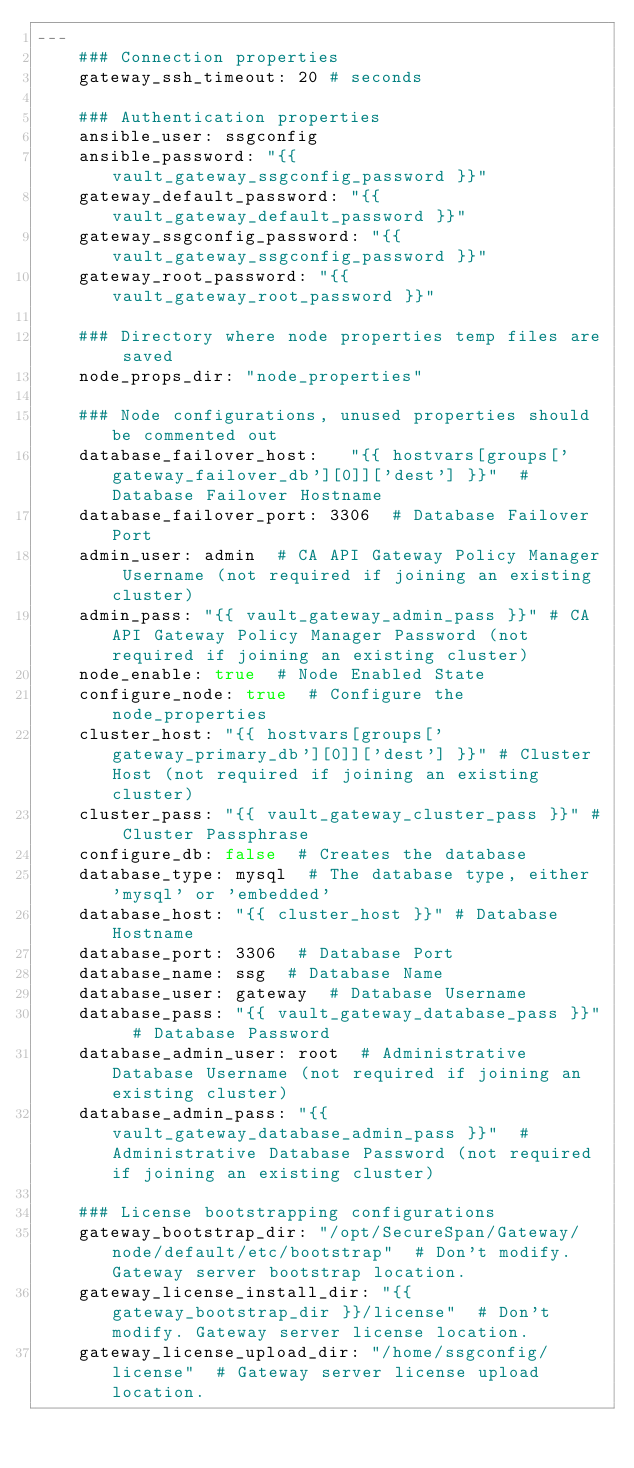Convert code to text. <code><loc_0><loc_0><loc_500><loc_500><_YAML_>---
    ### Connection properties
    gateway_ssh_timeout: 20 # seconds
    
    ### Authentication properties
    ansible_user: ssgconfig 
    ansible_password: "{{ vault_gateway_ssgconfig_password }}"
    gateway_default_password: "{{ vault_gateway_default_password }}"
    gateway_ssgconfig_password: "{{ vault_gateway_ssgconfig_password }}"
    gateway_root_password: "{{ vault_gateway_root_password }}"
    
    ### Directory where node properties temp files are saved
    node_props_dir: "node_properties"
    
    ### Node configurations, unused properties should be commented out
    database_failover_host:   "{{ hostvars[groups['gateway_failover_db'][0]]['dest'] }}"  # Database Failover Hostname
    database_failover_port: 3306  # Database Failover Port
    admin_user: admin  # CA API Gateway Policy Manager Username (not required if joining an existing cluster)
    admin_pass: "{{ vault_gateway_admin_pass }}" # CA API Gateway Policy Manager Password (not required if joining an existing cluster)
    node_enable: true  # Node Enabled State
    configure_node: true  # Configure the node_properties
    cluster_host: "{{ hostvars[groups['gateway_primary_db'][0]]['dest'] }}" # Cluster Host (not required if joining an existing cluster)
    cluster_pass: "{{ vault_gateway_cluster_pass }}" # Cluster Passphrase
    configure_db: false  # Creates the database
    database_type: mysql  # The database type, either 'mysql' or 'embedded'
    database_host: "{{ cluster_host }}" # Database Hostname
    database_port: 3306  # Database Port
    database_name: ssg  # Database Name
    database_user: gateway  # Database Username
    database_pass: "{{ vault_gateway_database_pass }}"  # Database Password
    database_admin_user: root  # Administrative Database Username (not required if joining an existing cluster)
    database_admin_pass: "{{ vault_gateway_database_admin_pass }}"  # Administrative Database Password (not required if joining an existing cluster)
    
    ### License bootstrapping configurations
    gateway_bootstrap_dir: "/opt/SecureSpan/Gateway/node/default/etc/bootstrap"  # Don't modify. Gateway server bootstrap location. 
    gateway_license_install_dir: "{{ gateway_bootstrap_dir }}/license"  # Don't modify. Gateway server license location.
    gateway_license_upload_dir: "/home/ssgconfig/license"  # Gateway server license upload location.
</code> 